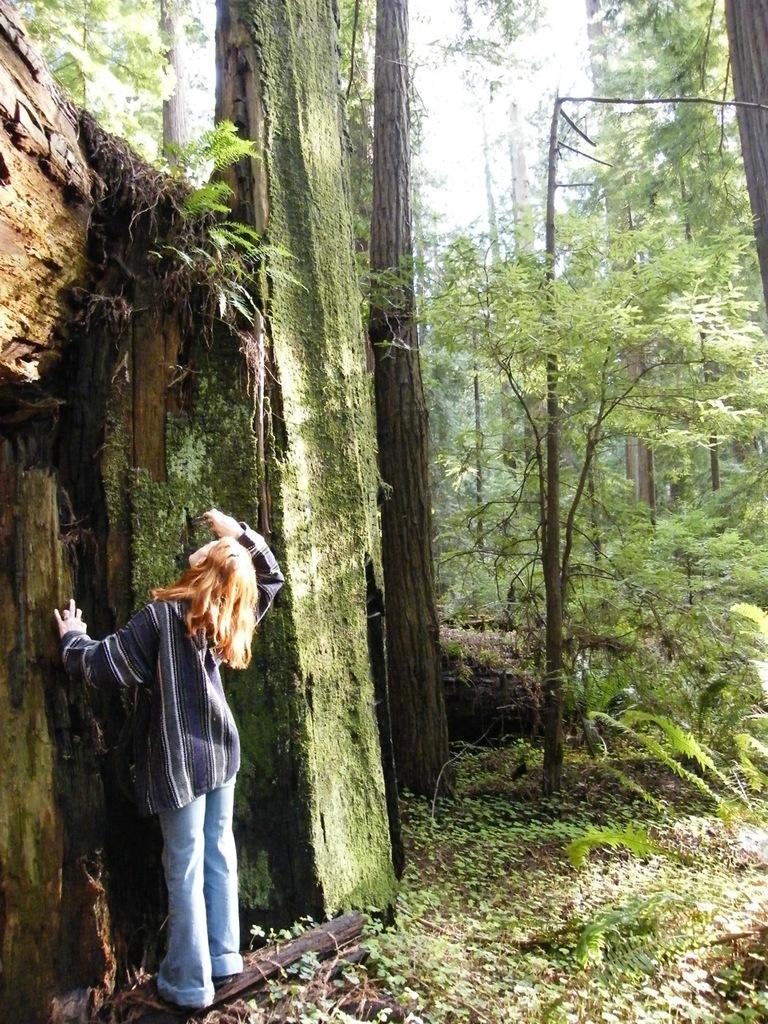Can you describe this image briefly? In this picture we can see a person standing. There are plants, trees and the sky. 